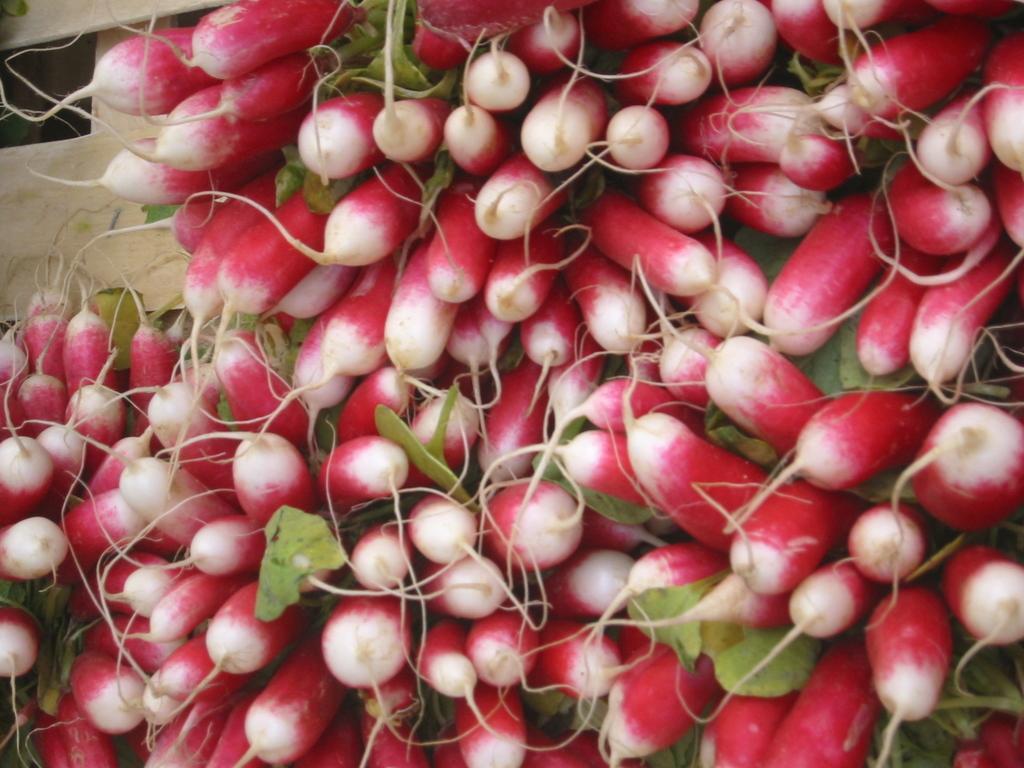Can you describe this image briefly? In this picture there are vegetables and there are leaves. At the back there is a wooden object. 